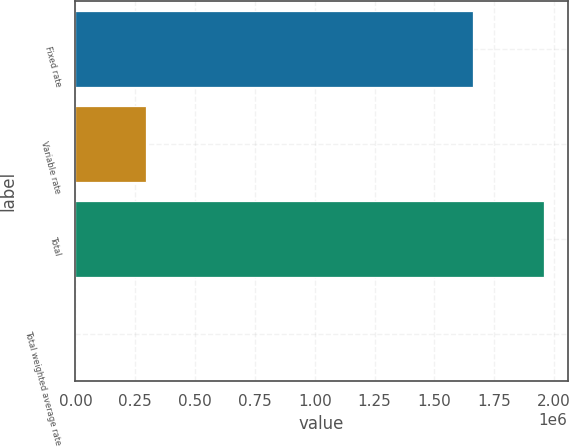Convert chart. <chart><loc_0><loc_0><loc_500><loc_500><bar_chart><fcel>Fixed rate<fcel>Variable rate<fcel>Total<fcel>Total weighted average rate<nl><fcel>1.66317e+06<fcel>295265<fcel>1.95843e+06<fcel>6.14<nl></chart> 